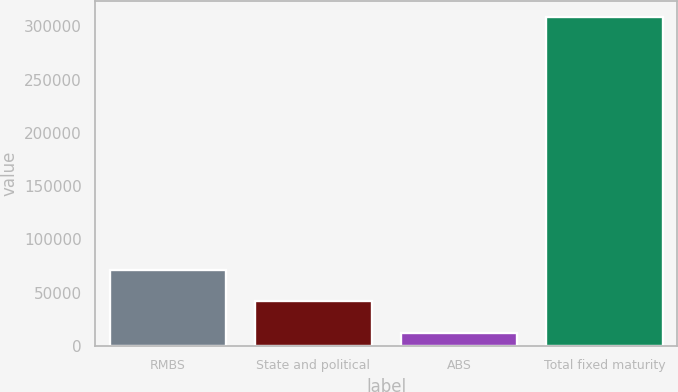<chart> <loc_0><loc_0><loc_500><loc_500><bar_chart><fcel>RMBS<fcel>State and political<fcel>ABS<fcel>Total fixed maturity<nl><fcel>71619<fcel>41955<fcel>12291<fcel>308931<nl></chart> 